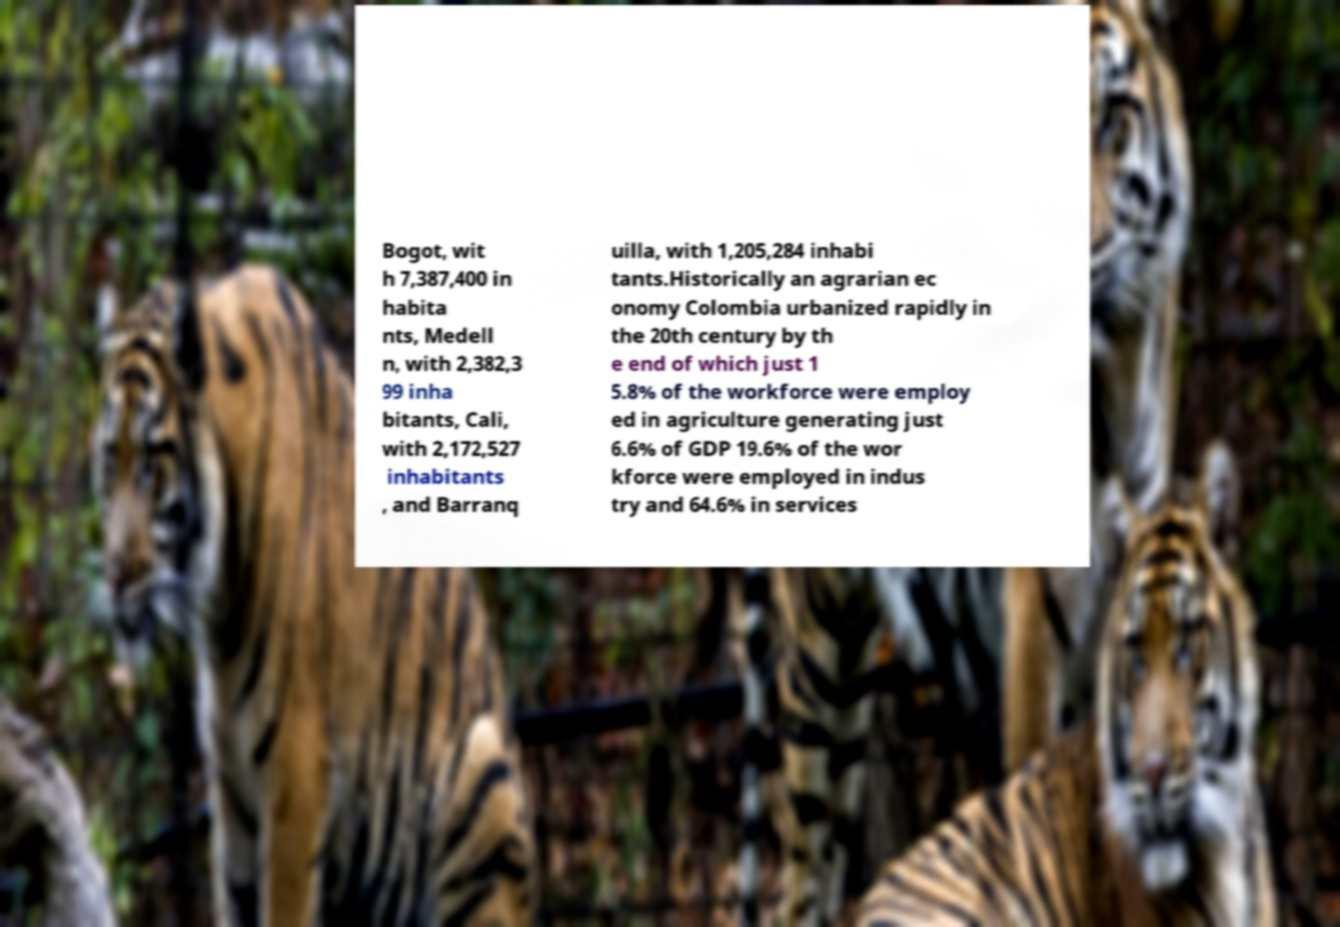I need the written content from this picture converted into text. Can you do that? Bogot, wit h 7,387,400 in habita nts, Medell n, with 2,382,3 99 inha bitants, Cali, with 2,172,527 inhabitants , and Barranq uilla, with 1,205,284 inhabi tants.Historically an agrarian ec onomy Colombia urbanized rapidly in the 20th century by th e end of which just 1 5.8% of the workforce were employ ed in agriculture generating just 6.6% of GDP 19.6% of the wor kforce were employed in indus try and 64.6% in services 